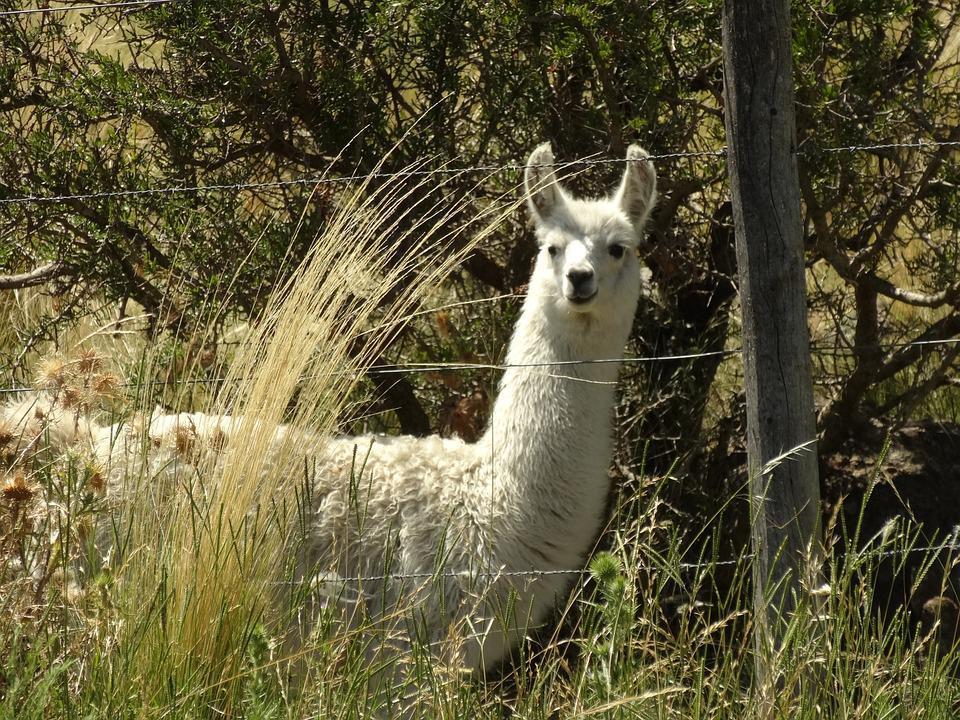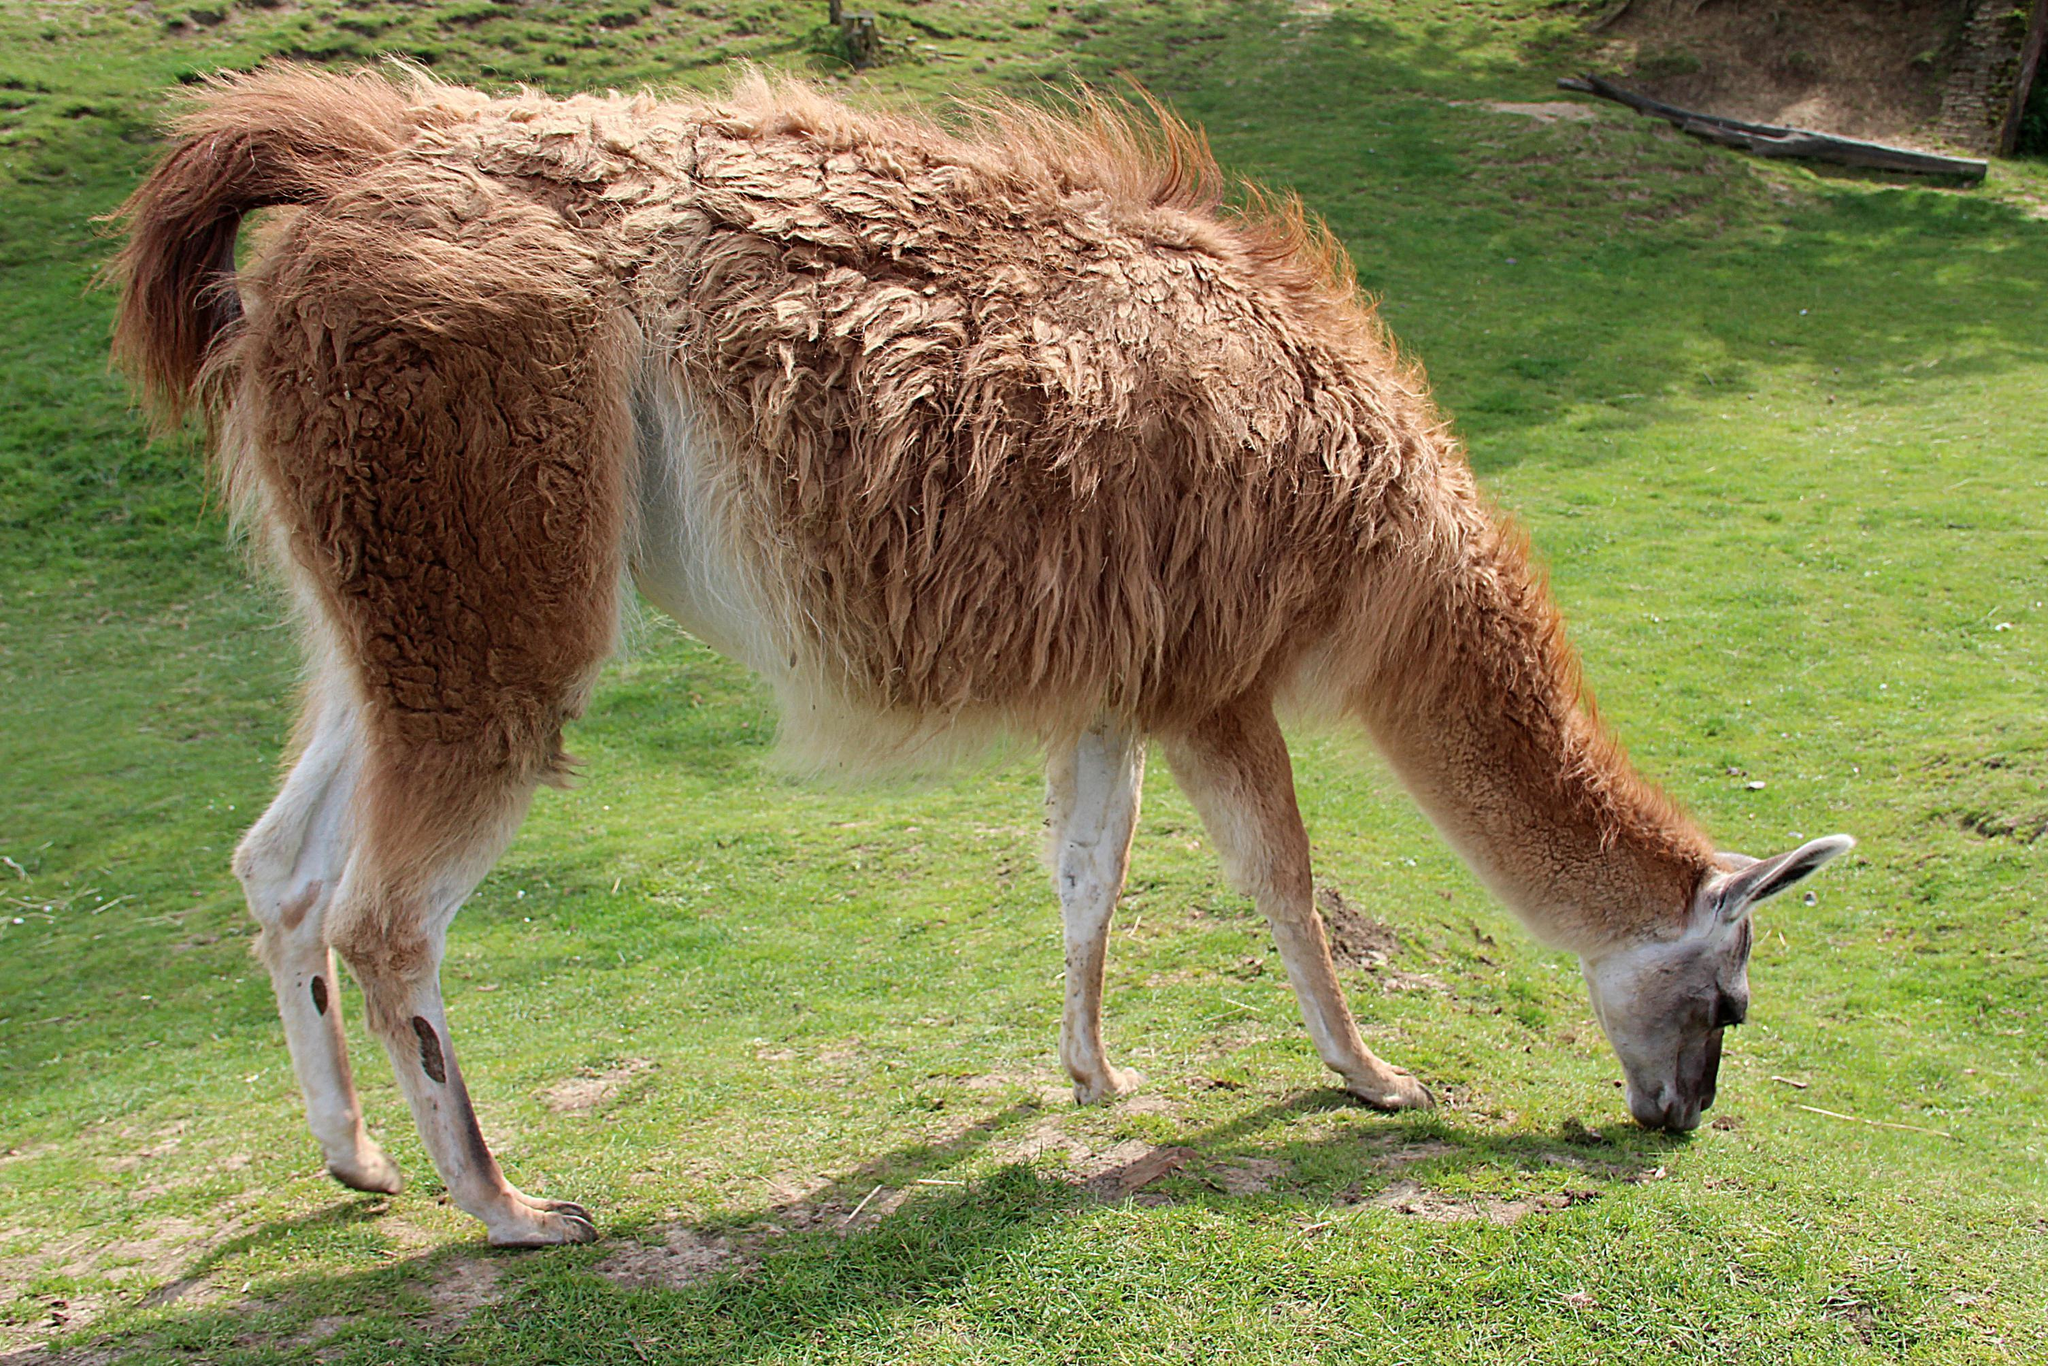The first image is the image on the left, the second image is the image on the right. Evaluate the accuracy of this statement regarding the images: "In one of the images, a llama has long strands of hay hanging out of its mouth.". Is it true? Answer yes or no. No. The first image is the image on the left, the second image is the image on the right. Examine the images to the left and right. Is the description "In at least one image there is a single brown llama eating yellow hay." accurate? Answer yes or no. No. 